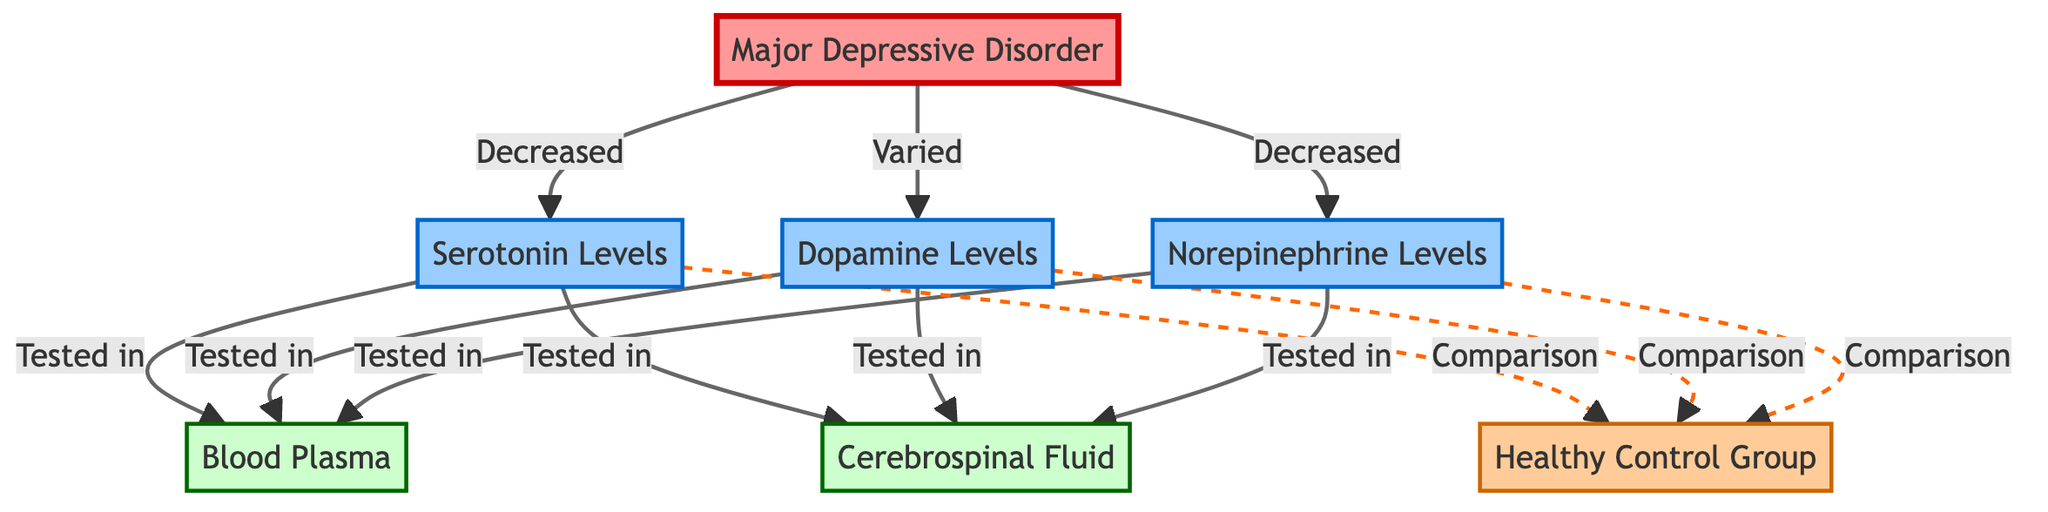What disorder is represented in the diagram? The diagram labels the first node as "Major Depressive Disorder," directly indicating the specific disorder that is the focus of the analysis.
Answer: Major Depressive Disorder How many neurotransmitter levels are depicted in the diagram? There are three neurotransmitter levels shown: Serotonin, Dopamine, and Norepinephrine, which can be counted from the labeled nodes in the diagram.
Answer: Three What is the relationship between Major Depressive Disorder and Serotonin Levels? The arrow from "Major Depressive Disorder" to "Serotonin Levels" is labeled "Decreased," indicating a negative relationship where serotonin levels decrease in this disorder.
Answer: Decreased How are Dopamine Levels tested in the study? The diagram shows two arrows pointing to "Dopamine Levels" from "Blood Plasma" and "Cerebrospinal Fluid," which represent the two tests conducted for dopamine levels.
Answer: Blood Plasma and Cerebrospinal Fluid What type of comparison does the diagram suggest for neurotransmitter levels? The dashed lines indicate a type of comparison noted as "Comparison" for Serotonin, Dopamine, and Norepinephrine levels with the "Healthy Control Group," which has been visually separated with a different line style.
Answer: Comparison Which neurotransmitter shows varied levels in patients with Major Depressive Disorder? The diagram specifically indicates that Dopamine Levels are "Varied," represented by the label connected to that node.
Answer: Varied In how many different types of tests are the neurotransmitter levels assessed? The diagram shows that all three neurotransmitters are tested in two types of tests: Blood Plasma and Cerebrospinal Fluid, which can be recognized by the connections from each neurotransmitter level to these test nodes.
Answer: Two What does the double-dashed line connect? The double-dashed lines in the diagram connect each neurotransmitter level to the "Healthy Control Group," indicating comparisons between affected patients and healthy individuals, as denoted by the unique line style.
Answer: Healthy Control Group 